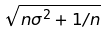Convert formula to latex. <formula><loc_0><loc_0><loc_500><loc_500>\sqrt { n \sigma ^ { 2 } + 1 / n }</formula> 